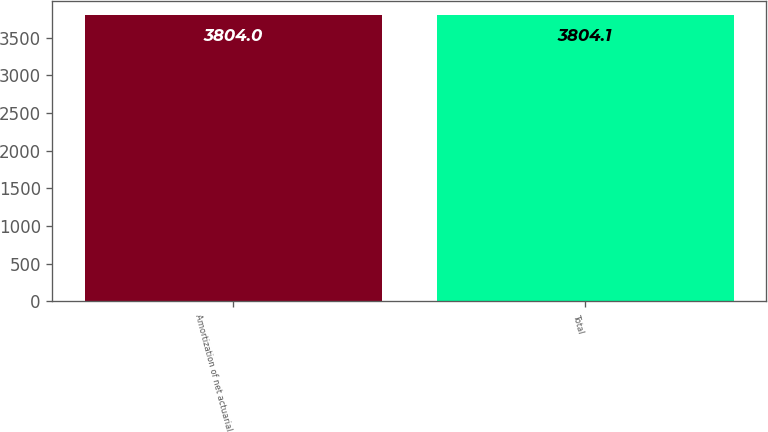Convert chart to OTSL. <chart><loc_0><loc_0><loc_500><loc_500><bar_chart><fcel>Amortization of net actuarial<fcel>Total<nl><fcel>3804<fcel>3804.1<nl></chart> 